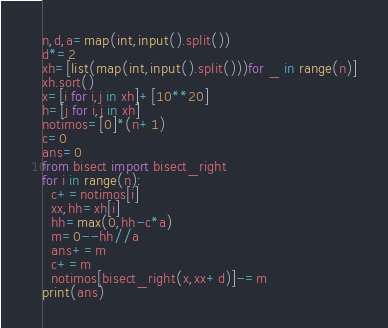<code> <loc_0><loc_0><loc_500><loc_500><_Python_>n,d,a=map(int,input().split())
d*=2
xh=[list(map(int,input().split()))for _ in range(n)]
xh.sort()
x=[i for i,j in xh]+[10**20]
h=[j for i,j in xh]
notimos=[0]*(n+1)
c=0
ans=0
from bisect import bisect_right
for i in range(n):
  c+=notimos[i]
  xx,hh=xh[i]
  hh=max(0,hh-c*a)
  m=0--hh//a
  ans+=m
  c+=m
  notimos[bisect_right(x,xx+d)]-=m
print(ans)</code> 